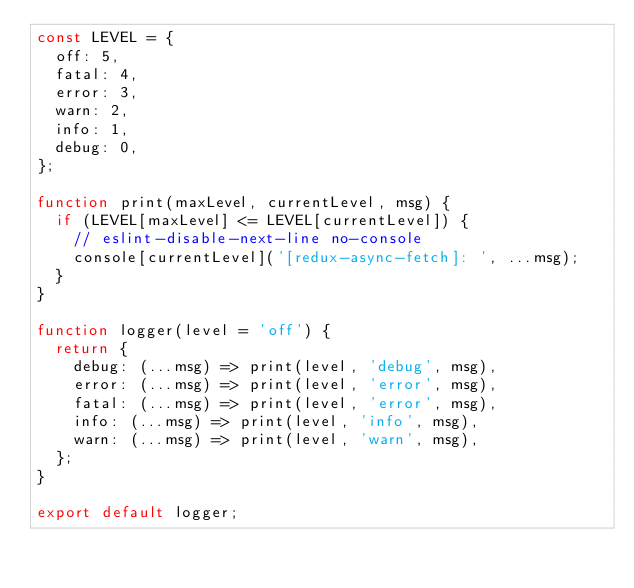<code> <loc_0><loc_0><loc_500><loc_500><_JavaScript_>const LEVEL = {
  off: 5,
  fatal: 4,
  error: 3,
  warn: 2,
  info: 1,
  debug: 0,
};

function print(maxLevel, currentLevel, msg) {
  if (LEVEL[maxLevel] <= LEVEL[currentLevel]) {
    // eslint-disable-next-line no-console
    console[currentLevel]('[redux-async-fetch]: ', ...msg);
  }
}

function logger(level = 'off') {
  return {
    debug: (...msg) => print(level, 'debug', msg),
    error: (...msg) => print(level, 'error', msg),
    fatal: (...msg) => print(level, 'error', msg),
    info: (...msg) => print(level, 'info', msg),
    warn: (...msg) => print(level, 'warn', msg),
  };
}

export default logger;
</code> 